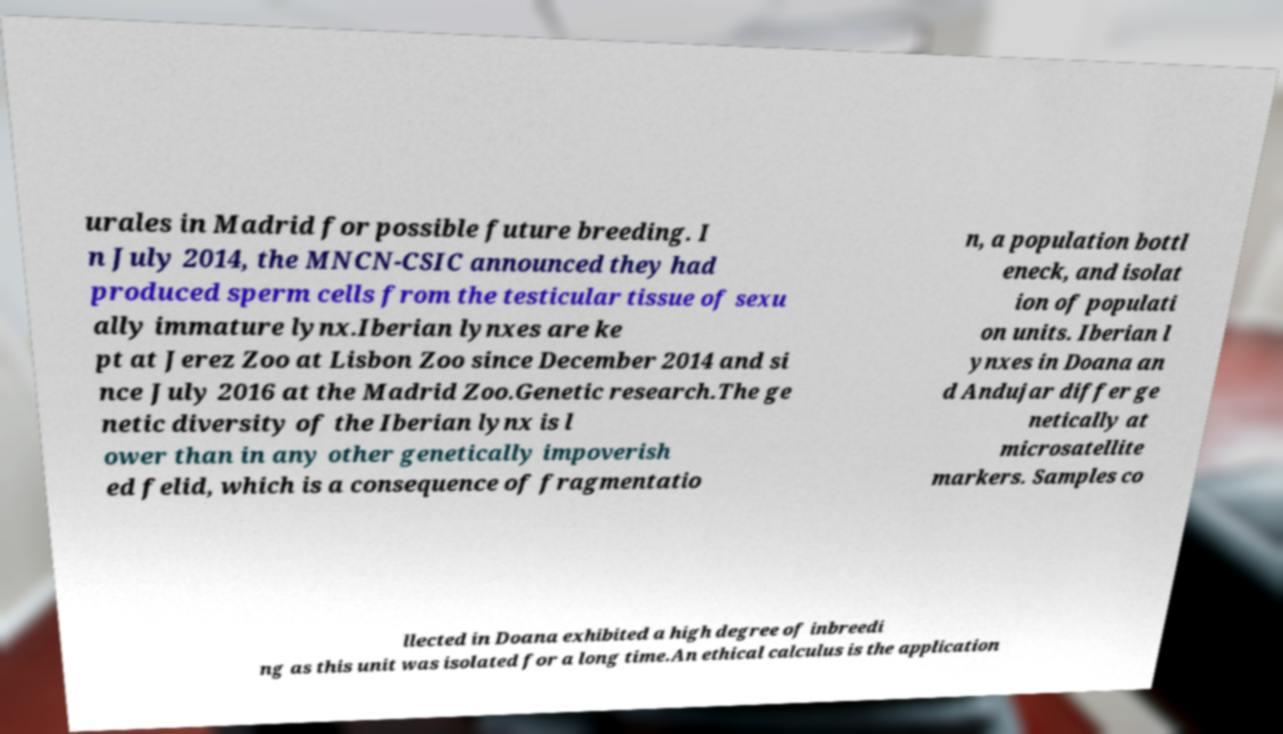What messages or text are displayed in this image? I need them in a readable, typed format. urales in Madrid for possible future breeding. I n July 2014, the MNCN-CSIC announced they had produced sperm cells from the testicular tissue of sexu ally immature lynx.Iberian lynxes are ke pt at Jerez Zoo at Lisbon Zoo since December 2014 and si nce July 2016 at the Madrid Zoo.Genetic research.The ge netic diversity of the Iberian lynx is l ower than in any other genetically impoverish ed felid, which is a consequence of fragmentatio n, a population bottl eneck, and isolat ion of populati on units. Iberian l ynxes in Doana an d Andujar differ ge netically at microsatellite markers. Samples co llected in Doana exhibited a high degree of inbreedi ng as this unit was isolated for a long time.An ethical calculus is the application 